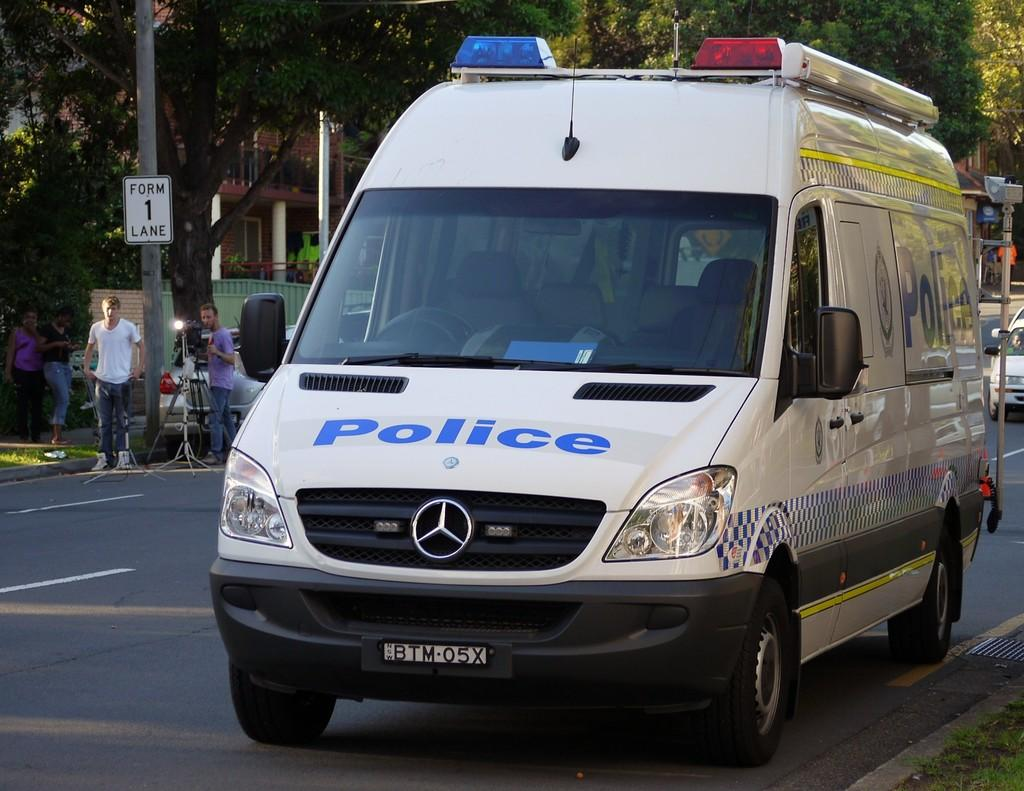<image>
Create a compact narrative representing the image presented. A big white van with sirens on top says Police on the front in blue letters. 